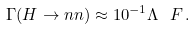Convert formula to latex. <formula><loc_0><loc_0><loc_500><loc_500>\Gamma ( H \rightarrow n n ) \approx 1 0 ^ { - 1 } \Lambda _ { \ } F \, .</formula> 